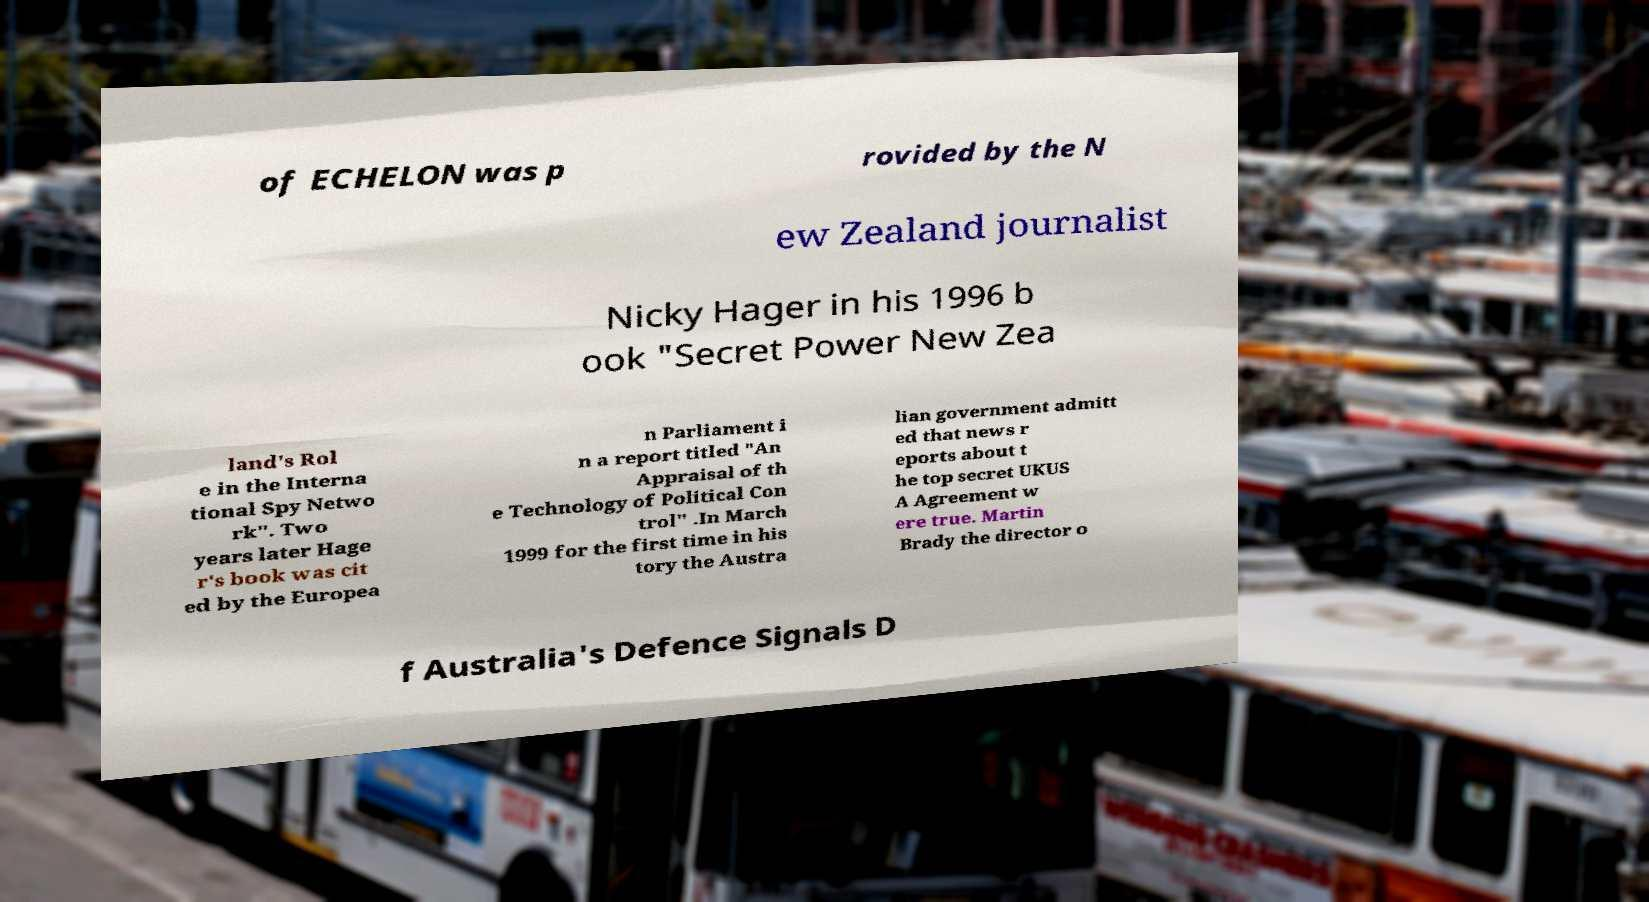For documentation purposes, I need the text within this image transcribed. Could you provide that? of ECHELON was p rovided by the N ew Zealand journalist Nicky Hager in his 1996 b ook "Secret Power New Zea land's Rol e in the Interna tional Spy Netwo rk". Two years later Hage r's book was cit ed by the Europea n Parliament i n a report titled "An Appraisal of th e Technology of Political Con trol" .In March 1999 for the first time in his tory the Austra lian government admitt ed that news r eports about t he top secret UKUS A Agreement w ere true. Martin Brady the director o f Australia's Defence Signals D 